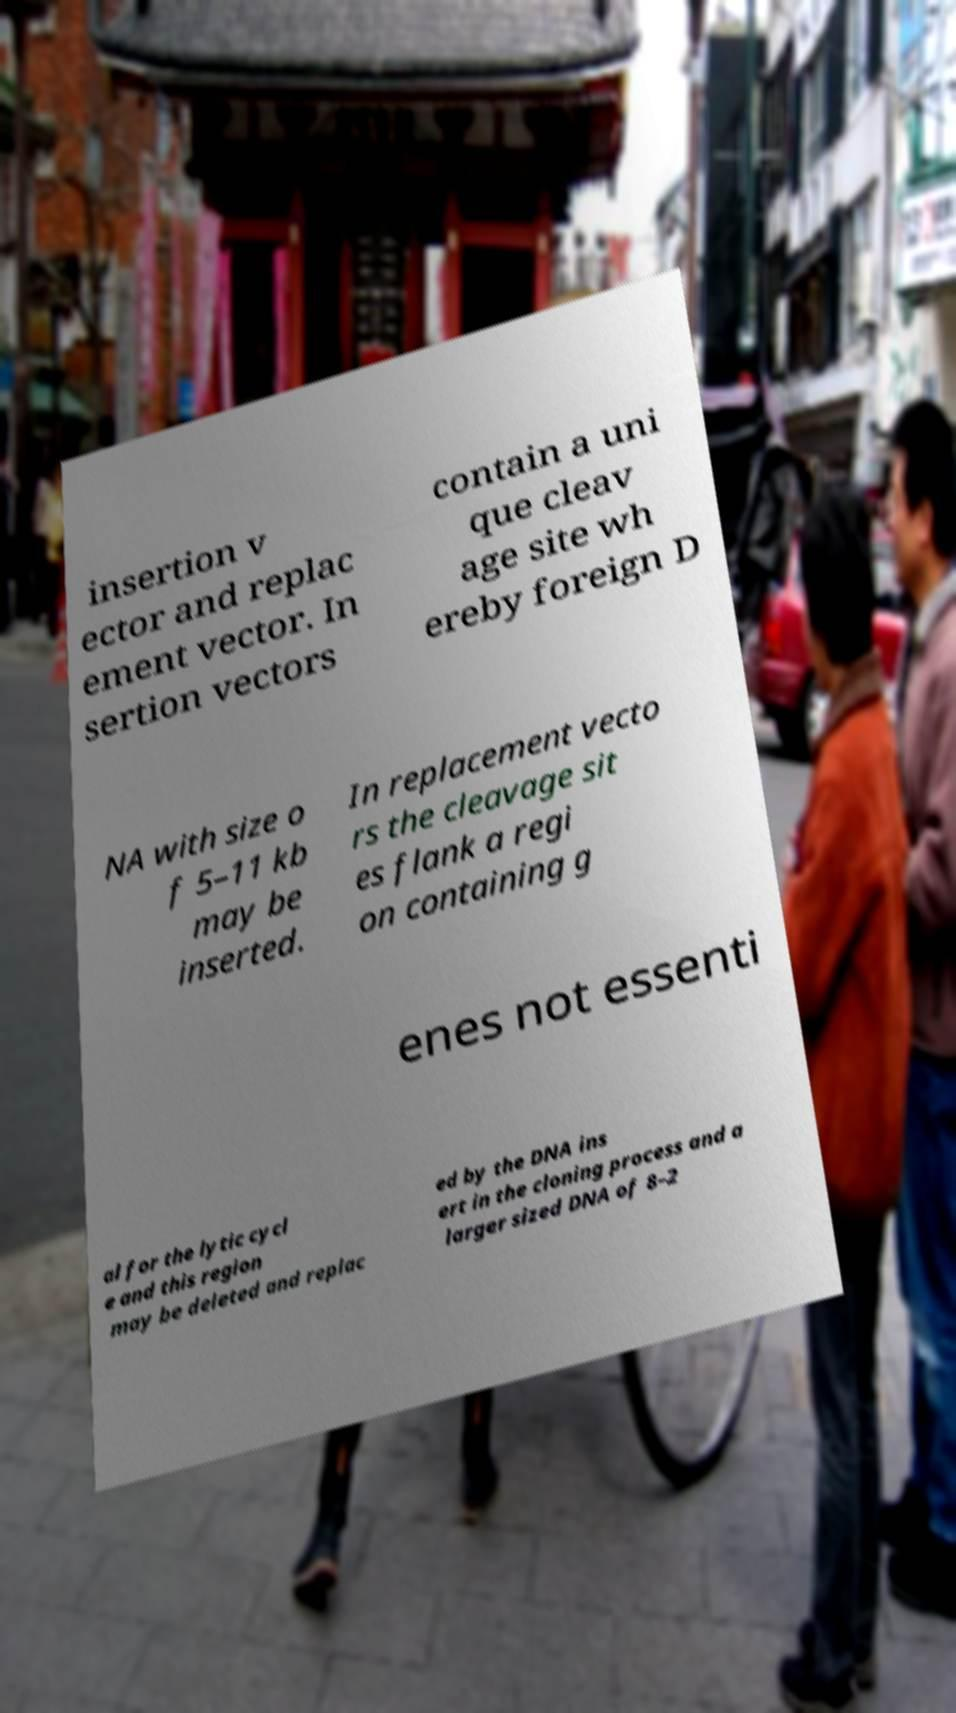I need the written content from this picture converted into text. Can you do that? insertion v ector and replac ement vector. In sertion vectors contain a uni que cleav age site wh ereby foreign D NA with size o f 5–11 kb may be inserted. In replacement vecto rs the cleavage sit es flank a regi on containing g enes not essenti al for the lytic cycl e and this region may be deleted and replac ed by the DNA ins ert in the cloning process and a larger sized DNA of 8–2 